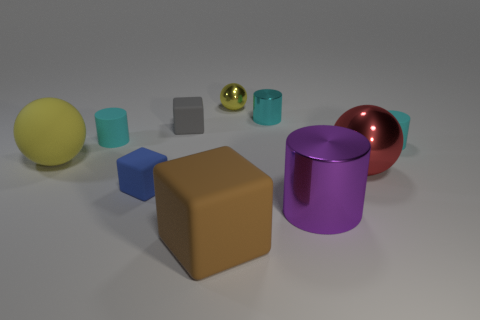Subtract all brown spheres. How many cyan cylinders are left? 3 Subtract all cylinders. How many objects are left? 6 Subtract all tiny cyan metal cylinders. Subtract all large brown cubes. How many objects are left? 8 Add 1 metallic objects. How many metallic objects are left? 5 Add 9 cyan metal things. How many cyan metal things exist? 10 Subtract 0 blue cylinders. How many objects are left? 10 